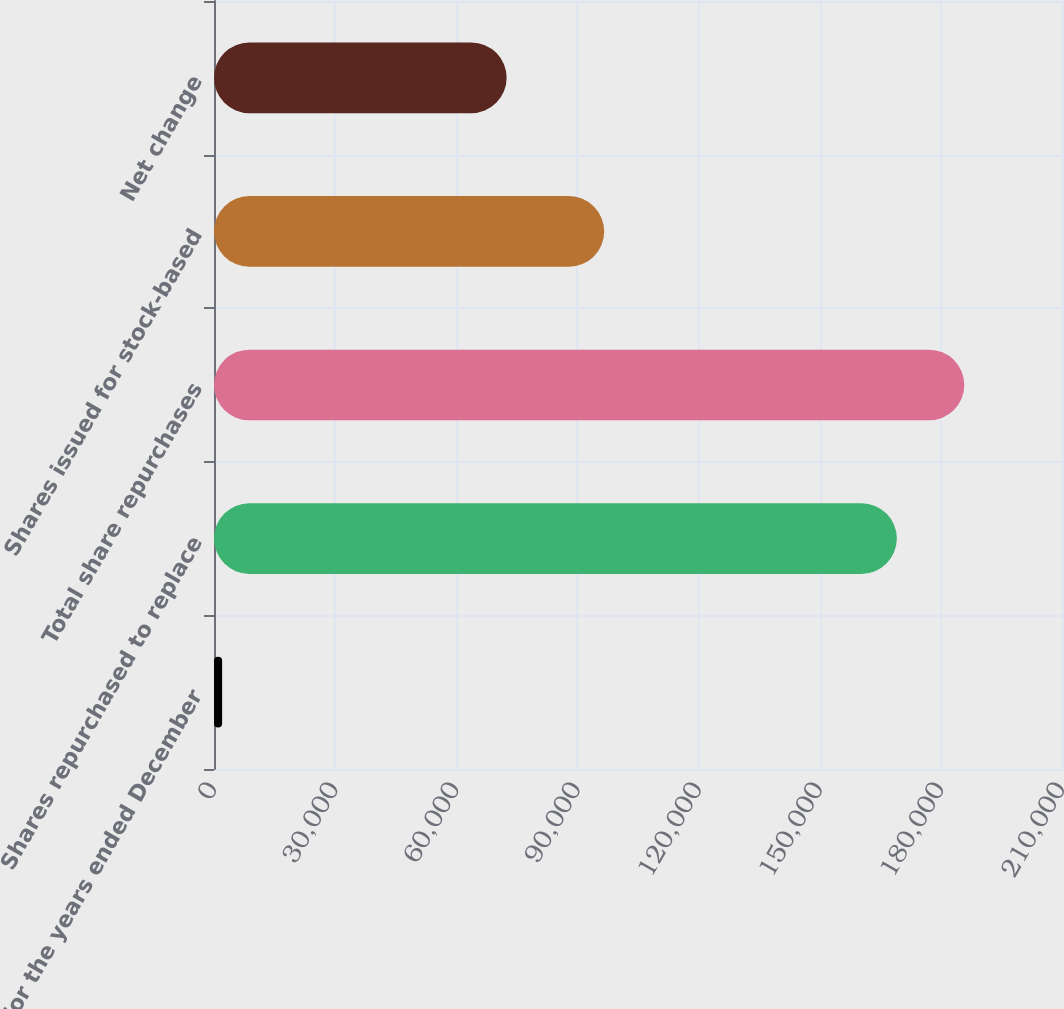Convert chart. <chart><loc_0><loc_0><loc_500><loc_500><bar_chart><fcel>For the years ended December<fcel>Shares repurchased to replace<fcel>Total share repurchases<fcel>Shares issued for stock-based<fcel>Net change<nl><fcel>2010<fcel>169099<fcel>185808<fcel>96627<fcel>72472<nl></chart> 